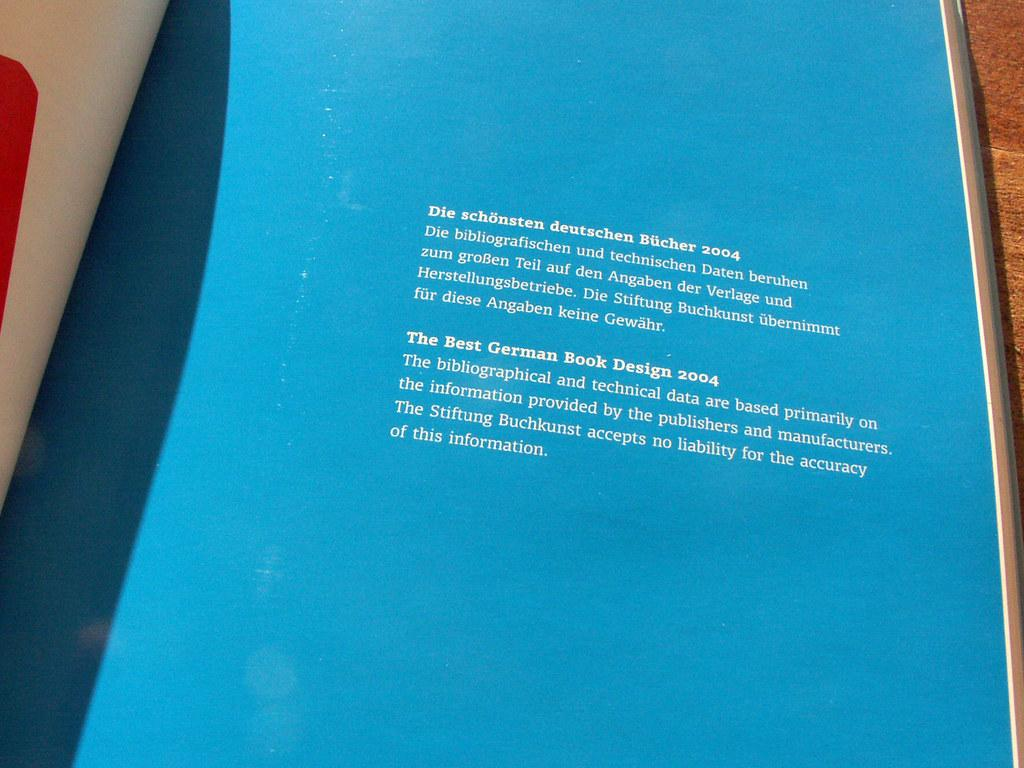Provide a one-sentence caption for the provided image. a blue sign that has many words, the first of which is die. 